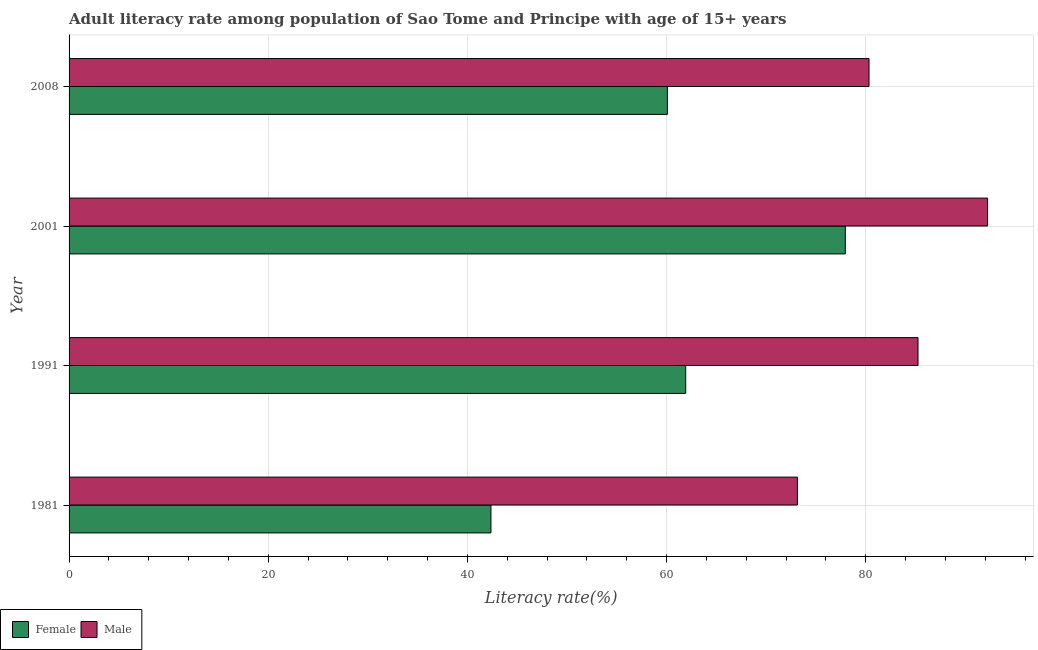How many groups of bars are there?
Offer a terse response. 4. How many bars are there on the 4th tick from the bottom?
Your answer should be very brief. 2. What is the label of the 1st group of bars from the top?
Provide a short and direct response. 2008. What is the female adult literacy rate in 2001?
Your response must be concise. 77.95. Across all years, what is the maximum female adult literacy rate?
Give a very brief answer. 77.95. Across all years, what is the minimum female adult literacy rate?
Provide a short and direct response. 42.36. In which year was the female adult literacy rate minimum?
Ensure brevity in your answer.  1981. What is the total male adult literacy rate in the graph?
Your answer should be very brief. 330.96. What is the difference between the male adult literacy rate in 1981 and that in 2001?
Provide a short and direct response. -19.09. What is the difference between the female adult literacy rate in 1981 and the male adult literacy rate in 1991?
Give a very brief answer. -42.89. What is the average female adult literacy rate per year?
Give a very brief answer. 60.58. In the year 2001, what is the difference between the female adult literacy rate and male adult literacy rate?
Offer a terse response. -14.29. What is the ratio of the male adult literacy rate in 1981 to that in 2001?
Your response must be concise. 0.79. Is the female adult literacy rate in 1991 less than that in 2008?
Give a very brief answer. No. Is the difference between the male adult literacy rate in 1991 and 2001 greater than the difference between the female adult literacy rate in 1991 and 2001?
Give a very brief answer. Yes. What is the difference between the highest and the second highest male adult literacy rate?
Your answer should be compact. 6.99. What is the difference between the highest and the lowest female adult literacy rate?
Keep it short and to the point. 35.59. Is the sum of the male adult literacy rate in 2001 and 2008 greater than the maximum female adult literacy rate across all years?
Your answer should be very brief. Yes. What does the 1st bar from the top in 2001 represents?
Keep it short and to the point. Male. Are all the bars in the graph horizontal?
Provide a succinct answer. Yes. How many years are there in the graph?
Provide a succinct answer. 4. What is the difference between two consecutive major ticks on the X-axis?
Offer a very short reply. 20. What is the title of the graph?
Your answer should be compact. Adult literacy rate among population of Sao Tome and Principe with age of 15+ years. Does "Borrowers" appear as one of the legend labels in the graph?
Make the answer very short. No. What is the label or title of the X-axis?
Your response must be concise. Literacy rate(%). What is the label or title of the Y-axis?
Offer a terse response. Year. What is the Literacy rate(%) in Female in 1981?
Keep it short and to the point. 42.36. What is the Literacy rate(%) of Male in 1981?
Provide a succinct answer. 73.14. What is the Literacy rate(%) in Female in 1991?
Provide a succinct answer. 61.92. What is the Literacy rate(%) of Male in 1991?
Your answer should be very brief. 85.25. What is the Literacy rate(%) in Female in 2001?
Offer a very short reply. 77.95. What is the Literacy rate(%) in Male in 2001?
Give a very brief answer. 92.23. What is the Literacy rate(%) in Female in 2008?
Offer a very short reply. 60.08. What is the Literacy rate(%) in Male in 2008?
Provide a succinct answer. 80.33. Across all years, what is the maximum Literacy rate(%) of Female?
Provide a succinct answer. 77.95. Across all years, what is the maximum Literacy rate(%) in Male?
Ensure brevity in your answer.  92.23. Across all years, what is the minimum Literacy rate(%) of Female?
Your answer should be very brief. 42.36. Across all years, what is the minimum Literacy rate(%) of Male?
Your answer should be very brief. 73.14. What is the total Literacy rate(%) of Female in the graph?
Your answer should be compact. 242.32. What is the total Literacy rate(%) of Male in the graph?
Make the answer very short. 330.96. What is the difference between the Literacy rate(%) of Female in 1981 and that in 1991?
Offer a terse response. -19.56. What is the difference between the Literacy rate(%) of Male in 1981 and that in 1991?
Your answer should be very brief. -12.11. What is the difference between the Literacy rate(%) in Female in 1981 and that in 2001?
Provide a succinct answer. -35.59. What is the difference between the Literacy rate(%) in Male in 1981 and that in 2001?
Provide a succinct answer. -19.09. What is the difference between the Literacy rate(%) in Female in 1981 and that in 2008?
Ensure brevity in your answer.  -17.72. What is the difference between the Literacy rate(%) of Male in 1981 and that in 2008?
Provide a short and direct response. -7.19. What is the difference between the Literacy rate(%) of Female in 1991 and that in 2001?
Ensure brevity in your answer.  -16.03. What is the difference between the Literacy rate(%) in Male in 1991 and that in 2001?
Provide a short and direct response. -6.99. What is the difference between the Literacy rate(%) of Female in 1991 and that in 2008?
Make the answer very short. 1.84. What is the difference between the Literacy rate(%) of Male in 1991 and that in 2008?
Offer a very short reply. 4.92. What is the difference between the Literacy rate(%) in Female in 2001 and that in 2008?
Keep it short and to the point. 17.87. What is the difference between the Literacy rate(%) of Male in 2001 and that in 2008?
Your answer should be very brief. 11.9. What is the difference between the Literacy rate(%) of Female in 1981 and the Literacy rate(%) of Male in 1991?
Offer a terse response. -42.89. What is the difference between the Literacy rate(%) of Female in 1981 and the Literacy rate(%) of Male in 2001?
Your answer should be compact. -49.87. What is the difference between the Literacy rate(%) of Female in 1981 and the Literacy rate(%) of Male in 2008?
Provide a succinct answer. -37.97. What is the difference between the Literacy rate(%) of Female in 1991 and the Literacy rate(%) of Male in 2001?
Provide a succinct answer. -30.31. What is the difference between the Literacy rate(%) of Female in 1991 and the Literacy rate(%) of Male in 2008?
Ensure brevity in your answer.  -18.41. What is the difference between the Literacy rate(%) in Female in 2001 and the Literacy rate(%) in Male in 2008?
Ensure brevity in your answer.  -2.38. What is the average Literacy rate(%) in Female per year?
Make the answer very short. 60.58. What is the average Literacy rate(%) of Male per year?
Offer a very short reply. 82.74. In the year 1981, what is the difference between the Literacy rate(%) in Female and Literacy rate(%) in Male?
Your answer should be very brief. -30.78. In the year 1991, what is the difference between the Literacy rate(%) in Female and Literacy rate(%) in Male?
Your response must be concise. -23.33. In the year 2001, what is the difference between the Literacy rate(%) in Female and Literacy rate(%) in Male?
Make the answer very short. -14.29. In the year 2008, what is the difference between the Literacy rate(%) of Female and Literacy rate(%) of Male?
Provide a succinct answer. -20.25. What is the ratio of the Literacy rate(%) of Female in 1981 to that in 1991?
Provide a short and direct response. 0.68. What is the ratio of the Literacy rate(%) of Male in 1981 to that in 1991?
Keep it short and to the point. 0.86. What is the ratio of the Literacy rate(%) in Female in 1981 to that in 2001?
Keep it short and to the point. 0.54. What is the ratio of the Literacy rate(%) in Male in 1981 to that in 2001?
Ensure brevity in your answer.  0.79. What is the ratio of the Literacy rate(%) in Female in 1981 to that in 2008?
Give a very brief answer. 0.71. What is the ratio of the Literacy rate(%) of Male in 1981 to that in 2008?
Keep it short and to the point. 0.91. What is the ratio of the Literacy rate(%) in Female in 1991 to that in 2001?
Make the answer very short. 0.79. What is the ratio of the Literacy rate(%) of Male in 1991 to that in 2001?
Offer a very short reply. 0.92. What is the ratio of the Literacy rate(%) in Female in 1991 to that in 2008?
Give a very brief answer. 1.03. What is the ratio of the Literacy rate(%) in Male in 1991 to that in 2008?
Offer a very short reply. 1.06. What is the ratio of the Literacy rate(%) of Female in 2001 to that in 2008?
Provide a succinct answer. 1.3. What is the ratio of the Literacy rate(%) in Male in 2001 to that in 2008?
Your answer should be very brief. 1.15. What is the difference between the highest and the second highest Literacy rate(%) in Female?
Your answer should be very brief. 16.03. What is the difference between the highest and the second highest Literacy rate(%) of Male?
Ensure brevity in your answer.  6.99. What is the difference between the highest and the lowest Literacy rate(%) of Female?
Your answer should be compact. 35.59. What is the difference between the highest and the lowest Literacy rate(%) of Male?
Your answer should be compact. 19.09. 